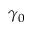<formula> <loc_0><loc_0><loc_500><loc_500>\gamma _ { 0 }</formula> 